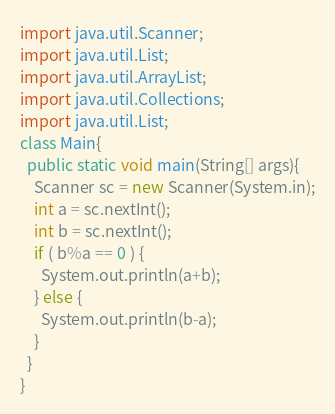<code> <loc_0><loc_0><loc_500><loc_500><_Java_>import java.util.Scanner;
import java.util.List;
import java.util.ArrayList;
import java.util.Collections;
import java.util.List;
class Main{
  public static void main(String[] args){
    Scanner sc = new Scanner(System.in);
	int a = sc.nextInt();
    int b = sc.nextInt();
    if ( b%a == 0 ) {
      System.out.println(a+b);
    } else {
      System.out.println(b-a);
    }
  }
}</code> 